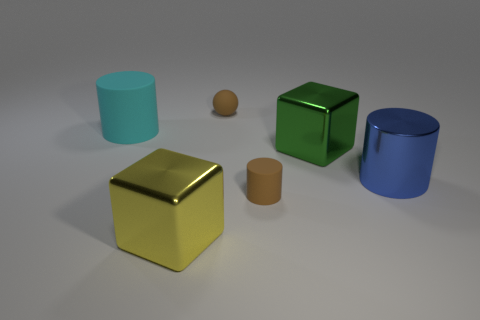There is another large object that is the same shape as the big green object; what color is it?
Keep it short and to the point. Yellow. Is the shape of the blue shiny thing the same as the yellow object?
Your answer should be very brief. No. What size is the other metallic thing that is the same shape as the green metallic thing?
Offer a terse response. Large. How many yellow balls have the same material as the green cube?
Provide a short and direct response. 0. What number of objects are either tiny gray spheres or big cyan things?
Offer a terse response. 1. There is a yellow metal cube that is to the left of the matte sphere; are there any things that are in front of it?
Provide a short and direct response. No. Are there more yellow metallic blocks that are behind the large cyan thing than metal cylinders left of the blue shiny cylinder?
Offer a very short reply. No. There is a small cylinder that is the same color as the small ball; what is its material?
Provide a succinct answer. Rubber. How many small objects are the same color as the metal cylinder?
Ensure brevity in your answer.  0. There is a metal block that is to the left of the green metallic block; is its color the same as the rubber cylinder right of the big matte cylinder?
Make the answer very short. No. 